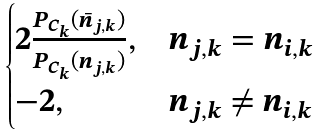Convert formula to latex. <formula><loc_0><loc_0><loc_500><loc_500>\begin{cases} 2 \frac { P _ { C _ { k } } ( \bar { n } _ { j , k } ) } { P _ { C _ { k } } ( n _ { j , k } ) } , & n _ { j , k } = n _ { i , k } \\ - 2 , & n _ { j , k } \ne n _ { i , k } \end{cases}</formula> 